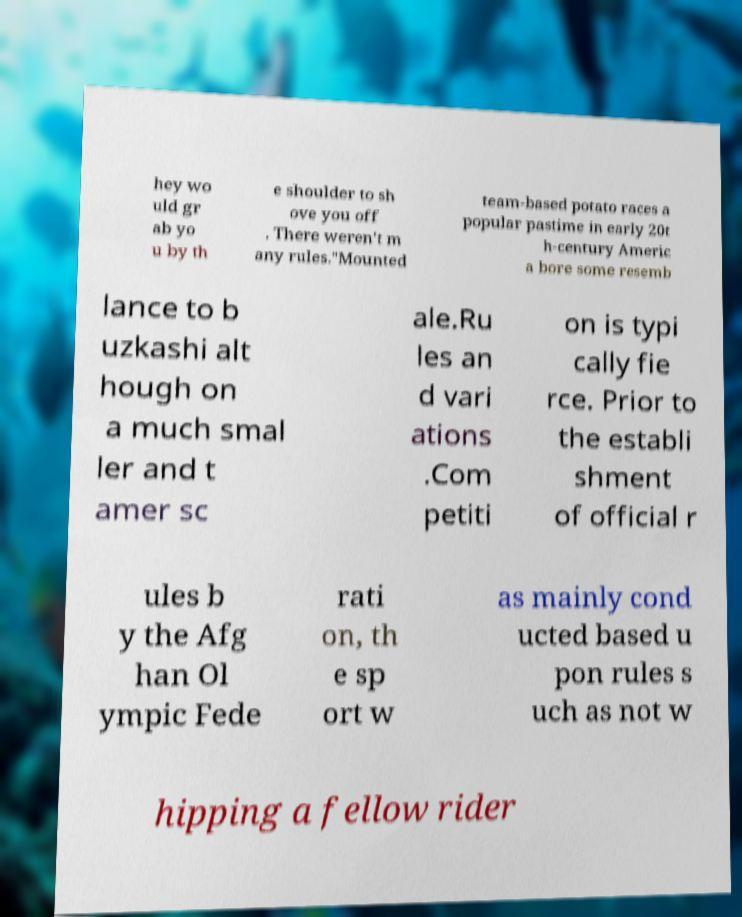Please identify and transcribe the text found in this image. hey wo uld gr ab yo u by th e shoulder to sh ove you off . There weren't m any rules."Mounted team-based potato races a popular pastime in early 20t h-century Americ a bore some resemb lance to b uzkashi alt hough on a much smal ler and t amer sc ale.Ru les an d vari ations .Com petiti on is typi cally fie rce. Prior to the establi shment of official r ules b y the Afg han Ol ympic Fede rati on, th e sp ort w as mainly cond ucted based u pon rules s uch as not w hipping a fellow rider 